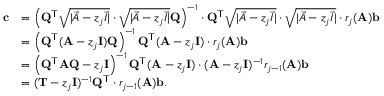<formula> <loc_0><loc_0><loc_500><loc_500>\begin{array} { r l } { c } & { = \left ( Q ^ { T } \sqrt { | \vec { A } - z _ { j } \vec { I } | } \cdot \sqrt { | \vec { A } - z _ { j } \vec { I } | } Q \right ) ^ { - 1 } \cdot Q ^ { T } \sqrt { | \vec { A } - z _ { j } \vec { I } | } \cdot \sqrt { | \vec { A } - z _ { j } \vec { I } | } \cdot r _ { j } ( A ) b } \\ & { = \left ( Q ^ { T } ( A - z _ { j } I ) Q \right ) ^ { - 1 } Q ^ { T } ( A - z _ { j } I ) \cdot r _ { j } ( A ) b } \\ & { = \left ( Q ^ { T } A Q - z _ { j } I \right ) ^ { - 1 } Q ^ { T } ( A - z _ { j } I ) \cdot ( A - z _ { j } I ) ^ { - 1 } r _ { j - 1 } ( A ) b } \\ & { = ( T - z _ { j } I ) ^ { - 1 } Q ^ { T } \cdot r _ { j - 1 } ( A ) b . } \end{array}</formula> 